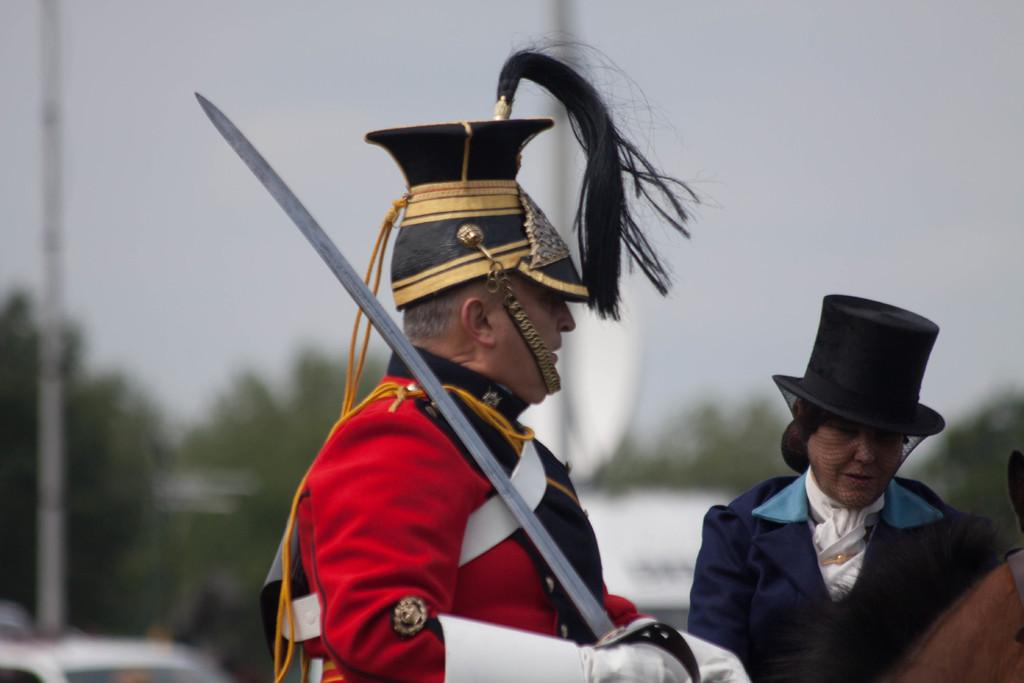How many people are in the image? There are two persons in the image. What else can be seen in the image besides the people? There is an animal and trees in the image. What is visible in the background of the image? The sky is visible in the background of the image. Where is the lunchroom in the image? There is no lunchroom present in the image. What type of paper is being used for arithmetic in the image? There is no paper or arithmetic activity present in the image. 